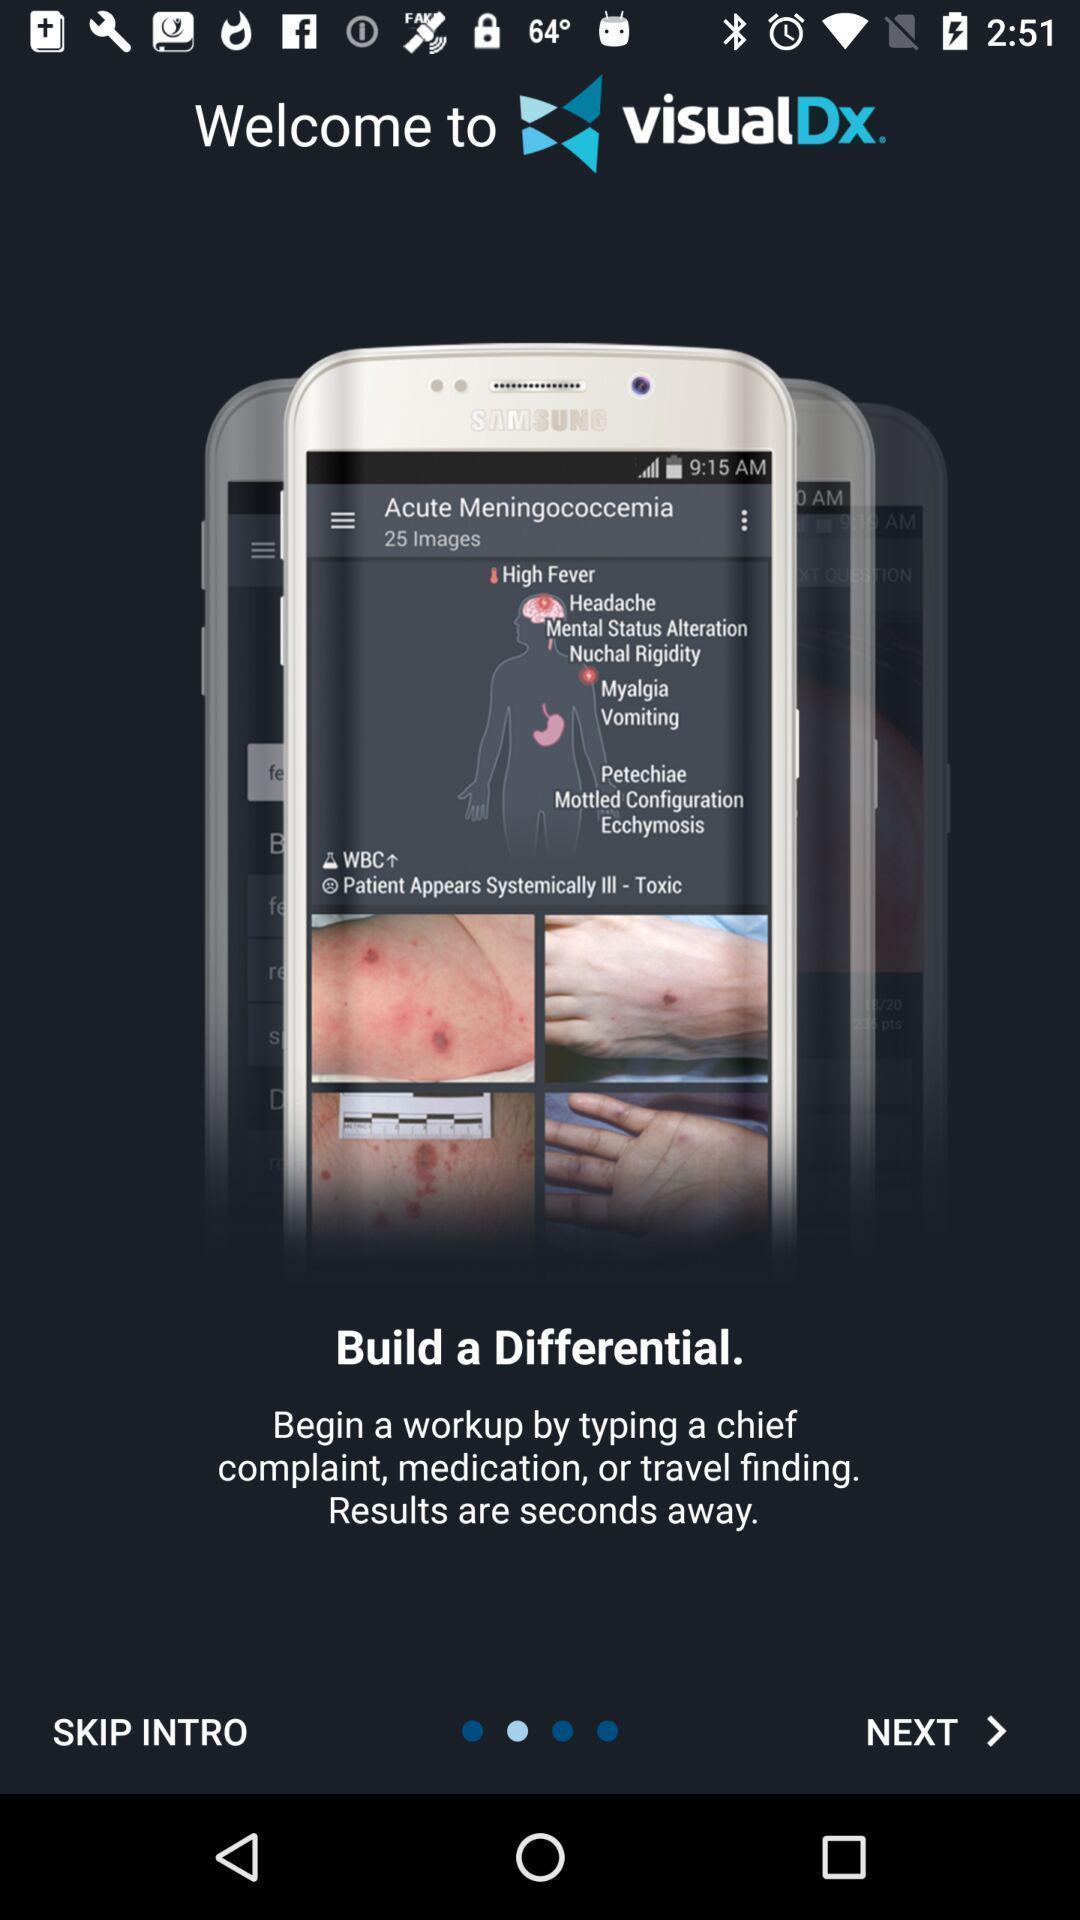Provide a textual representation of this image. Welcome page. 